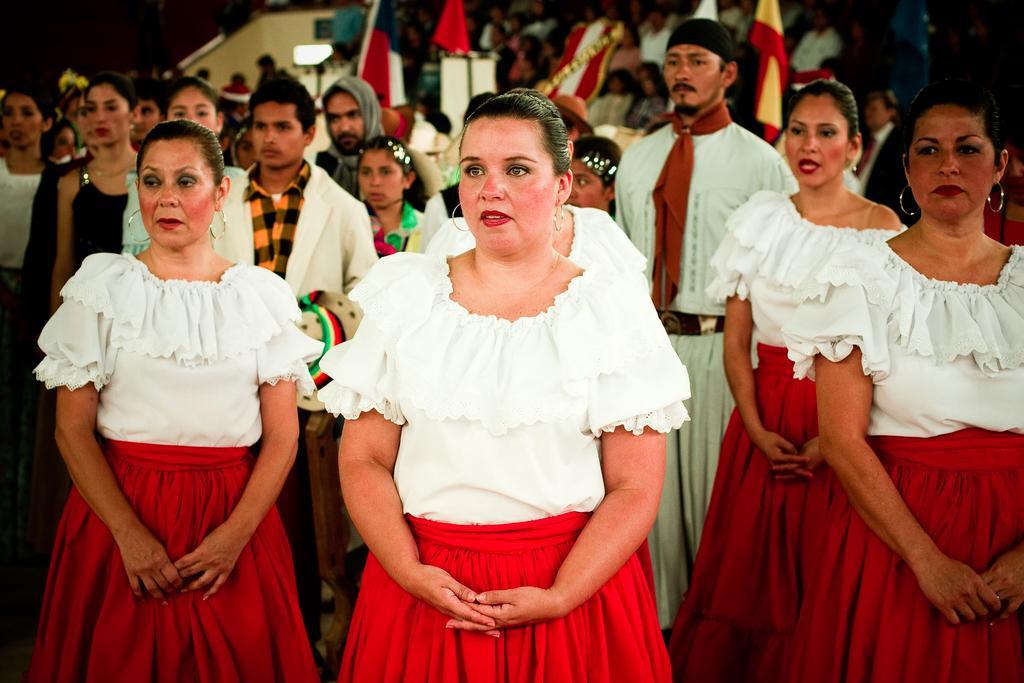In one or two sentences, can you explain what this image depicts? In this image, we can see a group of people. In the background, we can see a group of people , plants, building and flags. 